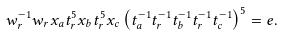<formula> <loc_0><loc_0><loc_500><loc_500>w _ { r } ^ { - 1 } w _ { r } x _ { a } t _ { r } ^ { 5 } x _ { b } t _ { r } ^ { 5 } x _ { c } \left ( t _ { a } ^ { - 1 } t _ { r } ^ { - 1 } t _ { b } ^ { - 1 } t _ { r } ^ { - 1 } t _ { c } ^ { - 1 } \right ) ^ { 5 } = e .</formula> 